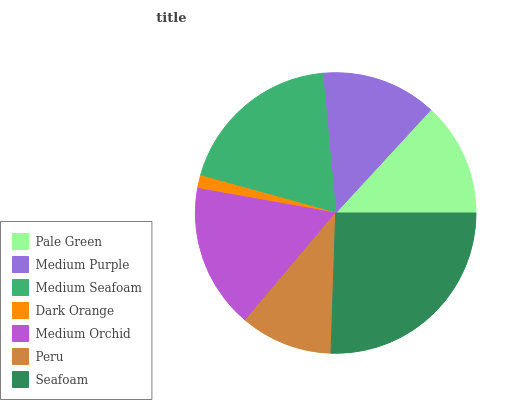Is Dark Orange the minimum?
Answer yes or no. Yes. Is Seafoam the maximum?
Answer yes or no. Yes. Is Medium Purple the minimum?
Answer yes or no. No. Is Medium Purple the maximum?
Answer yes or no. No. Is Medium Purple greater than Pale Green?
Answer yes or no. Yes. Is Pale Green less than Medium Purple?
Answer yes or no. Yes. Is Pale Green greater than Medium Purple?
Answer yes or no. No. Is Medium Purple less than Pale Green?
Answer yes or no. No. Is Medium Purple the high median?
Answer yes or no. Yes. Is Medium Purple the low median?
Answer yes or no. Yes. Is Pale Green the high median?
Answer yes or no. No. Is Dark Orange the low median?
Answer yes or no. No. 